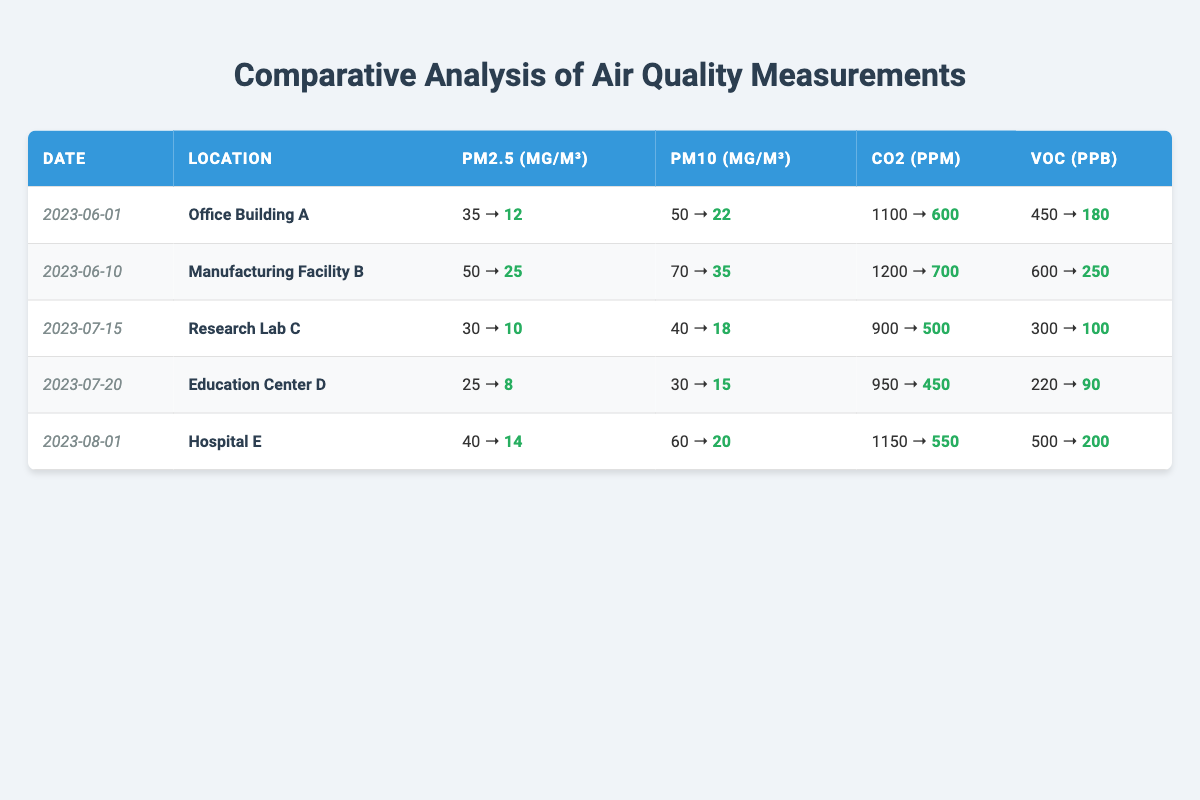What was the PM2.5 measurement at Office Building A before the ventilation improvements? The table shows that the PM2.5 measurement before the ventilation improvements at Office Building A was 35 µg/m³.
Answer: 35 µg/m³ What is the reduction in CO2 levels at Hospital E after implementing ventilation improvements? The CO2 level before improvements was 1150 ppm and after was 550 ppm. The reduction is calculated as 1150 - 550 = 600 ppm.
Answer: 600 ppm Did the PM10 levels increase or decrease at Research Lab C after ventilation improvements? In the table, PM10 levels decreased from 40 µg/m³ (before) to 18 µg/m³ (after), indicating a decrease.
Answer: Decrease Which location had the highest initial VOC measurement before ventilation improvements? Reviewing the table, Manufacturing Facility B had the highest initial VOC measurement of 600 ppb before the improvements.
Answer: Manufacturing Facility B What is the average PM2.5 measurement after the ventilation improvements across all locations? The table lists the after PM2.5 measurements as 12, 25, 10, 8, and 14 µg/m³. Summing these gives 12 + 25 + 10 + 8 + 14 = 69 µg/m³. The average is 69/5 = 13.8 µg/m³.
Answer: 13.8 µg/m³ Is the reduction in PM2.5 levels consistent across all locations? Each location shows a clear reduction in PM2.5 levels; however, the decrease is more pronounced in Research Lab C (20 µg/m³) than in Manufacturing Facility B (25 µg/m³). It is consistent but varies in magnitude.
Answer: Yes, but varies in magnitude Which location experienced the largest overall improvement in air quality based on CO2 reduction? At Manufacturing Facility B, CO2 levels decreased from 1200 ppm to 700 ppm, a reduction of 500 ppm, which is less than Hospital E's 600 ppm reduction indicating that Hospital E experienced the largest improvement in air quality based on CO2 reduction.
Answer: Hospital E What is the percentage reduction of VOC levels at Education Center D after ventilation improvements? The VOC level decreased from 220 ppb to 90 ppb. The reduction is 220 - 90 = 130 ppb. The percentage reduction is calculated as (130/220) * 100 = 59.09%.
Answer: 59.09% Name one location that had PM10 levels below 20 µg/m³ after improvements. The table shows that both Research Lab C and Hospital E had PM10 levels of 18 µg/m³ and 20 µg/m³ respectively after improvements, so Research Lab C fits this criterion.
Answer: Research Lab C 